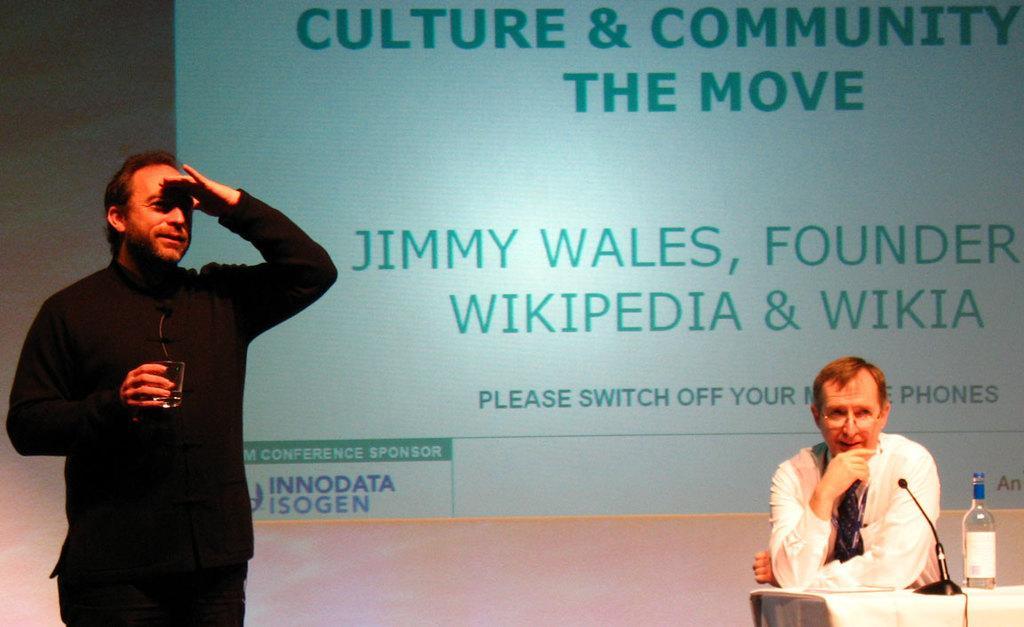Please provide a concise description of this image. In this picture we can observe two members. Both of them are men. One of them is sitting in the chair in front of a table on which we can observe a bottle and a mic and the other is a man wearing black color dress and holding a glass in his hand. In the background we can observe a projector display screen. 